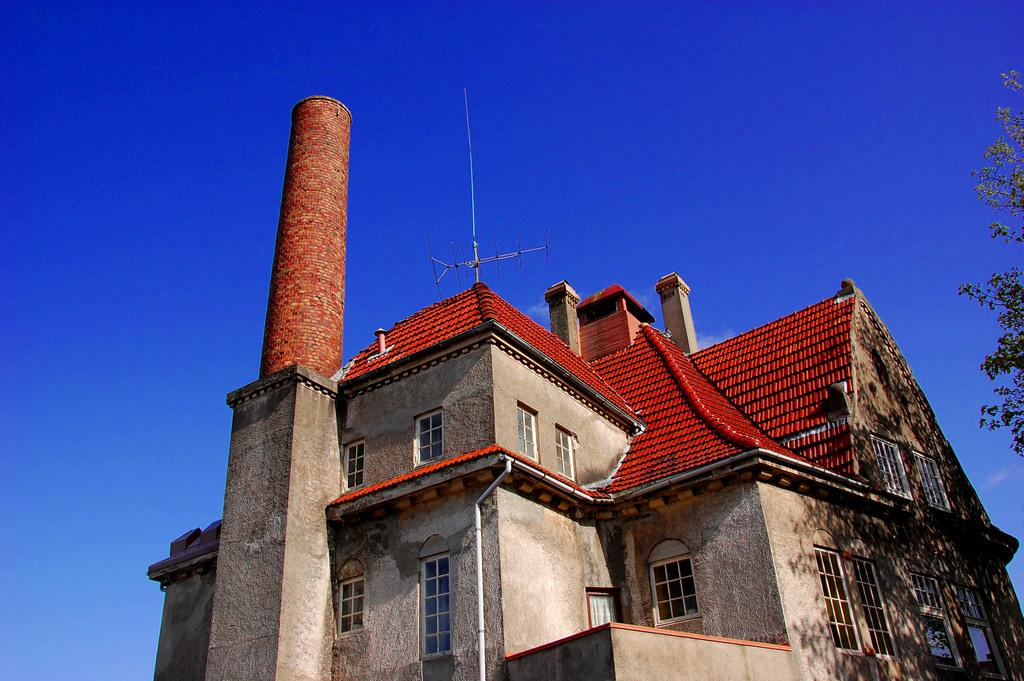What type of structure is present in the image? There is a building in the image. What is on top of the building? There is an antenna on the building. What other object can be seen in the image? There is a tree in the image. What can be seen in the background of the image? The sky is visible in the background of the image. How many bats are hanging from the tree in the image? There are no bats present in the image; it only features a building, an antenna, a tree, and the sky. What type of yak can be seen grazing near the building in the image? There are no yaks present in the image; it only features a building, an antenna, a tree, and the sky. 